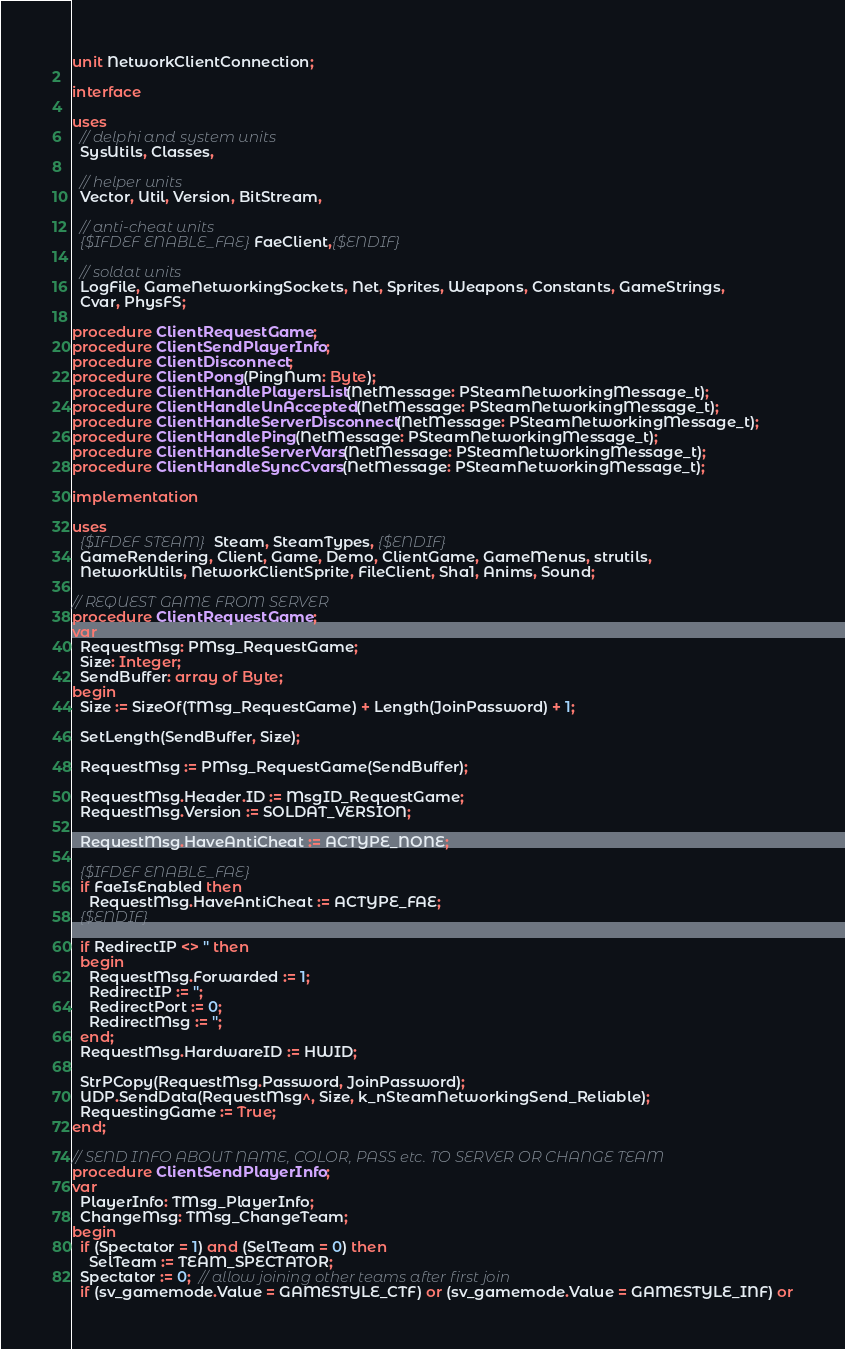<code> <loc_0><loc_0><loc_500><loc_500><_Pascal_>unit NetworkClientConnection;

interface

uses
  // delphi and system units
  SysUtils, Classes,

  // helper units
  Vector, Util, Version, BitStream,

  // anti-cheat units
  {$IFDEF ENABLE_FAE}FaeClient,{$ENDIF}

  // soldat units
  LogFile, GameNetworkingSockets, Net, Sprites, Weapons, Constants, GameStrings,
  Cvar, PhysFS;

procedure ClientRequestGame;
procedure ClientSendPlayerInfo;
procedure ClientDisconnect;
procedure ClientPong(PingNum: Byte);
procedure ClientHandlePlayersList(NetMessage: PSteamNetworkingMessage_t);
procedure ClientHandleUnAccepted(NetMessage: PSteamNetworkingMessage_t);
procedure ClientHandleServerDisconnect(NetMessage: PSteamNetworkingMessage_t);
procedure ClientHandlePing(NetMessage: PSteamNetworkingMessage_t);
procedure ClientHandleServerVars(NetMessage: PSteamNetworkingMessage_t);
procedure ClientHandleSyncCvars(NetMessage: PSteamNetworkingMessage_t);

implementation

uses
  {$IFDEF STEAM} Steam, SteamTypes, {$ENDIF}
  GameRendering, Client, Game, Demo, ClientGame, GameMenus, strutils,
  NetworkUtils, NetworkClientSprite, FileClient, Sha1, Anims, Sound;

// REQUEST GAME FROM SERVER
procedure ClientRequestGame;
var
  RequestMsg: PMsg_RequestGame;
  Size: Integer;
  SendBuffer: array of Byte;
begin
  Size := SizeOf(TMsg_RequestGame) + Length(JoinPassword) + 1;

  SetLength(SendBuffer, Size);

  RequestMsg := PMsg_RequestGame(SendBuffer);

  RequestMsg.Header.ID := MsgID_RequestGame;
  RequestMsg.Version := SOLDAT_VERSION;

  RequestMsg.HaveAntiCheat := ACTYPE_NONE;

  {$IFDEF ENABLE_FAE}
  if FaeIsEnabled then
    RequestMsg.HaveAntiCheat := ACTYPE_FAE;
  {$ENDIF}

  if RedirectIP <> '' then
  begin
    RequestMsg.Forwarded := 1;
    RedirectIP := '';
    RedirectPort := 0;
    RedirectMsg := '';
  end;
  RequestMsg.HardwareID := HWID;

  StrPCopy(RequestMsg.Password, JoinPassword);
  UDP.SendData(RequestMsg^, Size, k_nSteamNetworkingSend_Reliable);
  RequestingGame := True;
end;

// SEND INFO ABOUT NAME, COLOR, PASS etc. TO SERVER OR CHANGE TEAM
procedure ClientSendPlayerInfo;
var
  PlayerInfo: TMsg_PlayerInfo;
  ChangeMsg: TMsg_ChangeTeam;
begin
  if (Spectator = 1) and (SelTeam = 0) then
    SelTeam := TEAM_SPECTATOR;
  Spectator := 0;  // allow joining other teams after first join
  if (sv_gamemode.Value = GAMESTYLE_CTF) or (sv_gamemode.Value = GAMESTYLE_INF) or</code> 